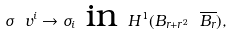Convert formula to latex. <formula><loc_0><loc_0><loc_500><loc_500>\sigma _ { \ } v ^ { i } \to \sigma _ { i } \text { in } H ^ { 1 } ( B _ { r + r ^ { 2 } } \ \overline { B _ { r } } ) ,</formula> 